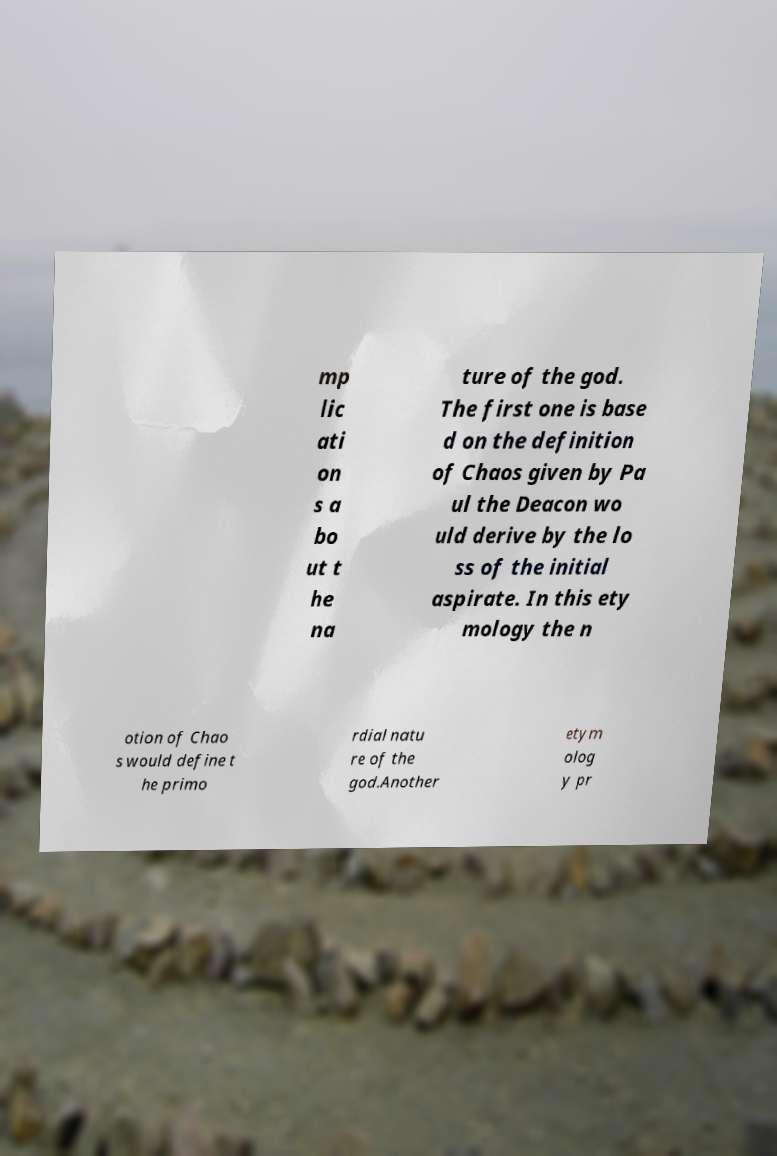Could you assist in decoding the text presented in this image and type it out clearly? mp lic ati on s a bo ut t he na ture of the god. The first one is base d on the definition of Chaos given by Pa ul the Deacon wo uld derive by the lo ss of the initial aspirate. In this ety mology the n otion of Chao s would define t he primo rdial natu re of the god.Another etym olog y pr 